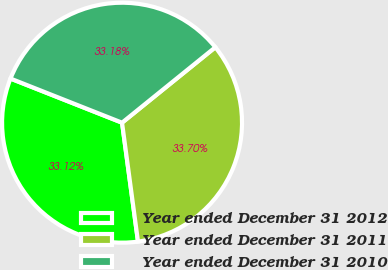<chart> <loc_0><loc_0><loc_500><loc_500><pie_chart><fcel>Year ended December 31 2012<fcel>Year ended December 31 2011<fcel>Year ended December 31 2010<nl><fcel>33.12%<fcel>33.7%<fcel>33.18%<nl></chart> 